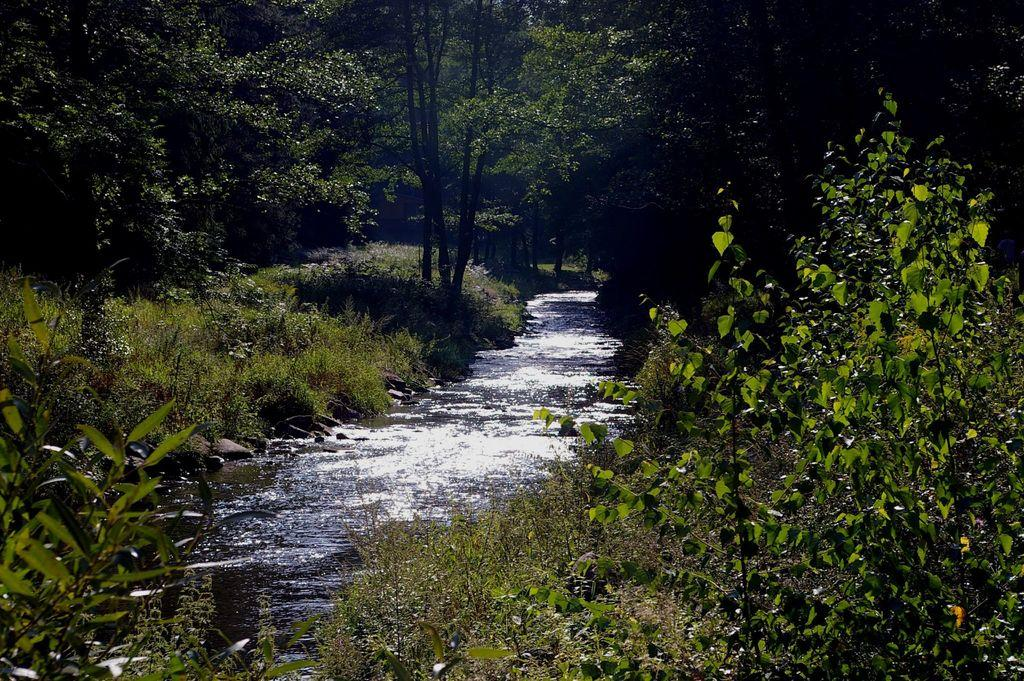What is located in the middle of the image? There is water in the middle of the image. What can be found at the bottom of the image? There are plants at the bottom of the image. What is visible in the background of the image? There are trees visible in the background of the image. How much payment is required to cross the river in the image? There is no river present in the image, and therefore no payment is required to cross it. What color is the orange in the image? There is no orange present in the image. 